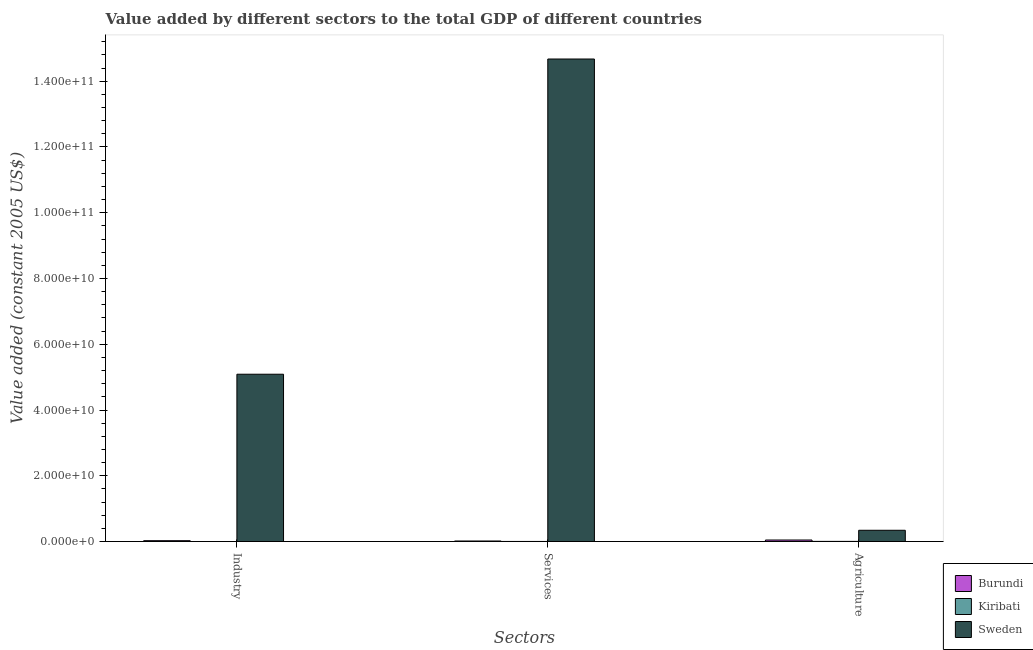How many groups of bars are there?
Provide a short and direct response. 3. Are the number of bars per tick equal to the number of legend labels?
Your response must be concise. Yes. How many bars are there on the 3rd tick from the right?
Make the answer very short. 3. What is the label of the 3rd group of bars from the left?
Provide a succinct answer. Agriculture. What is the value added by services in Kiribati?
Offer a terse response. 3.43e+07. Across all countries, what is the maximum value added by agricultural sector?
Make the answer very short. 3.43e+09. Across all countries, what is the minimum value added by industrial sector?
Your answer should be very brief. 6.78e+06. In which country was the value added by services maximum?
Your response must be concise. Sweden. In which country was the value added by services minimum?
Your answer should be very brief. Kiribati. What is the total value added by services in the graph?
Keep it short and to the point. 1.47e+11. What is the difference between the value added by industrial sector in Sweden and that in Burundi?
Your response must be concise. 5.06e+1. What is the difference between the value added by industrial sector in Burundi and the value added by services in Kiribati?
Provide a succinct answer. 2.32e+08. What is the average value added by agricultural sector per country?
Your response must be concise. 1.32e+09. What is the difference between the value added by services and value added by agricultural sector in Burundi?
Provide a succinct answer. -2.99e+08. What is the ratio of the value added by services in Burundi to that in Kiribati?
Give a very brief answer. 5.09. Is the value added by industrial sector in Sweden less than that in Kiribati?
Offer a very short reply. No. What is the difference between the highest and the second highest value added by industrial sector?
Offer a terse response. 5.06e+1. What is the difference between the highest and the lowest value added by industrial sector?
Your answer should be very brief. 5.09e+1. In how many countries, is the value added by industrial sector greater than the average value added by industrial sector taken over all countries?
Offer a very short reply. 1. Is the sum of the value added by agricultural sector in Kiribati and Sweden greater than the maximum value added by industrial sector across all countries?
Offer a very short reply. No. What does the 2nd bar from the left in Agriculture represents?
Offer a terse response. Kiribati. What does the 3rd bar from the right in Services represents?
Make the answer very short. Burundi. Is it the case that in every country, the sum of the value added by industrial sector and value added by services is greater than the value added by agricultural sector?
Your answer should be compact. No. What is the difference between two consecutive major ticks on the Y-axis?
Provide a short and direct response. 2.00e+1. Where does the legend appear in the graph?
Your response must be concise. Bottom right. What is the title of the graph?
Keep it short and to the point. Value added by different sectors to the total GDP of different countries. Does "Nepal" appear as one of the legend labels in the graph?
Ensure brevity in your answer.  No. What is the label or title of the X-axis?
Ensure brevity in your answer.  Sectors. What is the label or title of the Y-axis?
Provide a short and direct response. Value added (constant 2005 US$). What is the Value added (constant 2005 US$) of Burundi in Industry?
Ensure brevity in your answer.  2.66e+08. What is the Value added (constant 2005 US$) in Kiribati in Industry?
Give a very brief answer. 6.78e+06. What is the Value added (constant 2005 US$) in Sweden in Industry?
Your response must be concise. 5.09e+1. What is the Value added (constant 2005 US$) of Burundi in Services?
Provide a succinct answer. 1.75e+08. What is the Value added (constant 2005 US$) of Kiribati in Services?
Provide a short and direct response. 3.43e+07. What is the Value added (constant 2005 US$) of Sweden in Services?
Ensure brevity in your answer.  1.47e+11. What is the Value added (constant 2005 US$) in Burundi in Agriculture?
Your answer should be compact. 4.73e+08. What is the Value added (constant 2005 US$) in Kiribati in Agriculture?
Your answer should be compact. 5.42e+07. What is the Value added (constant 2005 US$) in Sweden in Agriculture?
Offer a terse response. 3.43e+09. Across all Sectors, what is the maximum Value added (constant 2005 US$) of Burundi?
Offer a very short reply. 4.73e+08. Across all Sectors, what is the maximum Value added (constant 2005 US$) in Kiribati?
Make the answer very short. 5.42e+07. Across all Sectors, what is the maximum Value added (constant 2005 US$) of Sweden?
Provide a short and direct response. 1.47e+11. Across all Sectors, what is the minimum Value added (constant 2005 US$) in Burundi?
Offer a very short reply. 1.75e+08. Across all Sectors, what is the minimum Value added (constant 2005 US$) of Kiribati?
Your answer should be very brief. 6.78e+06. Across all Sectors, what is the minimum Value added (constant 2005 US$) of Sweden?
Your answer should be very brief. 3.43e+09. What is the total Value added (constant 2005 US$) of Burundi in the graph?
Offer a terse response. 9.14e+08. What is the total Value added (constant 2005 US$) in Kiribati in the graph?
Ensure brevity in your answer.  9.53e+07. What is the total Value added (constant 2005 US$) in Sweden in the graph?
Your answer should be compact. 2.01e+11. What is the difference between the Value added (constant 2005 US$) of Burundi in Industry and that in Services?
Your answer should be very brief. 9.19e+07. What is the difference between the Value added (constant 2005 US$) in Kiribati in Industry and that in Services?
Keep it short and to the point. -2.75e+07. What is the difference between the Value added (constant 2005 US$) of Sweden in Industry and that in Services?
Keep it short and to the point. -9.59e+1. What is the difference between the Value added (constant 2005 US$) of Burundi in Industry and that in Agriculture?
Ensure brevity in your answer.  -2.07e+08. What is the difference between the Value added (constant 2005 US$) of Kiribati in Industry and that in Agriculture?
Offer a terse response. -4.74e+07. What is the difference between the Value added (constant 2005 US$) of Sweden in Industry and that in Agriculture?
Ensure brevity in your answer.  4.75e+1. What is the difference between the Value added (constant 2005 US$) of Burundi in Services and that in Agriculture?
Give a very brief answer. -2.99e+08. What is the difference between the Value added (constant 2005 US$) in Kiribati in Services and that in Agriculture?
Give a very brief answer. -1.99e+07. What is the difference between the Value added (constant 2005 US$) in Sweden in Services and that in Agriculture?
Provide a succinct answer. 1.43e+11. What is the difference between the Value added (constant 2005 US$) in Burundi in Industry and the Value added (constant 2005 US$) in Kiribati in Services?
Keep it short and to the point. 2.32e+08. What is the difference between the Value added (constant 2005 US$) in Burundi in Industry and the Value added (constant 2005 US$) in Sweden in Services?
Your answer should be very brief. -1.46e+11. What is the difference between the Value added (constant 2005 US$) of Kiribati in Industry and the Value added (constant 2005 US$) of Sweden in Services?
Offer a very short reply. -1.47e+11. What is the difference between the Value added (constant 2005 US$) of Burundi in Industry and the Value added (constant 2005 US$) of Kiribati in Agriculture?
Your answer should be very brief. 2.12e+08. What is the difference between the Value added (constant 2005 US$) in Burundi in Industry and the Value added (constant 2005 US$) in Sweden in Agriculture?
Ensure brevity in your answer.  -3.17e+09. What is the difference between the Value added (constant 2005 US$) of Kiribati in Industry and the Value added (constant 2005 US$) of Sweden in Agriculture?
Make the answer very short. -3.43e+09. What is the difference between the Value added (constant 2005 US$) in Burundi in Services and the Value added (constant 2005 US$) in Kiribati in Agriculture?
Ensure brevity in your answer.  1.20e+08. What is the difference between the Value added (constant 2005 US$) in Burundi in Services and the Value added (constant 2005 US$) in Sweden in Agriculture?
Provide a short and direct response. -3.26e+09. What is the difference between the Value added (constant 2005 US$) of Kiribati in Services and the Value added (constant 2005 US$) of Sweden in Agriculture?
Offer a very short reply. -3.40e+09. What is the average Value added (constant 2005 US$) of Burundi per Sectors?
Offer a very short reply. 3.05e+08. What is the average Value added (constant 2005 US$) in Kiribati per Sectors?
Provide a short and direct response. 3.18e+07. What is the average Value added (constant 2005 US$) in Sweden per Sectors?
Your response must be concise. 6.70e+1. What is the difference between the Value added (constant 2005 US$) of Burundi and Value added (constant 2005 US$) of Kiribati in Industry?
Your response must be concise. 2.60e+08. What is the difference between the Value added (constant 2005 US$) in Burundi and Value added (constant 2005 US$) in Sweden in Industry?
Your answer should be very brief. -5.06e+1. What is the difference between the Value added (constant 2005 US$) in Kiribati and Value added (constant 2005 US$) in Sweden in Industry?
Your response must be concise. -5.09e+1. What is the difference between the Value added (constant 2005 US$) of Burundi and Value added (constant 2005 US$) of Kiribati in Services?
Ensure brevity in your answer.  1.40e+08. What is the difference between the Value added (constant 2005 US$) of Burundi and Value added (constant 2005 US$) of Sweden in Services?
Your answer should be compact. -1.47e+11. What is the difference between the Value added (constant 2005 US$) in Kiribati and Value added (constant 2005 US$) in Sweden in Services?
Give a very brief answer. -1.47e+11. What is the difference between the Value added (constant 2005 US$) in Burundi and Value added (constant 2005 US$) in Kiribati in Agriculture?
Offer a terse response. 4.19e+08. What is the difference between the Value added (constant 2005 US$) of Burundi and Value added (constant 2005 US$) of Sweden in Agriculture?
Provide a short and direct response. -2.96e+09. What is the difference between the Value added (constant 2005 US$) of Kiribati and Value added (constant 2005 US$) of Sweden in Agriculture?
Provide a short and direct response. -3.38e+09. What is the ratio of the Value added (constant 2005 US$) of Burundi in Industry to that in Services?
Your response must be concise. 1.53. What is the ratio of the Value added (constant 2005 US$) in Kiribati in Industry to that in Services?
Offer a terse response. 0.2. What is the ratio of the Value added (constant 2005 US$) of Sweden in Industry to that in Services?
Your answer should be very brief. 0.35. What is the ratio of the Value added (constant 2005 US$) of Burundi in Industry to that in Agriculture?
Give a very brief answer. 0.56. What is the ratio of the Value added (constant 2005 US$) of Kiribati in Industry to that in Agriculture?
Offer a very short reply. 0.13. What is the ratio of the Value added (constant 2005 US$) of Sweden in Industry to that in Agriculture?
Offer a very short reply. 14.82. What is the ratio of the Value added (constant 2005 US$) in Burundi in Services to that in Agriculture?
Provide a succinct answer. 0.37. What is the ratio of the Value added (constant 2005 US$) of Kiribati in Services to that in Agriculture?
Keep it short and to the point. 0.63. What is the ratio of the Value added (constant 2005 US$) in Sweden in Services to that in Agriculture?
Your answer should be very brief. 42.75. What is the difference between the highest and the second highest Value added (constant 2005 US$) in Burundi?
Make the answer very short. 2.07e+08. What is the difference between the highest and the second highest Value added (constant 2005 US$) in Kiribati?
Keep it short and to the point. 1.99e+07. What is the difference between the highest and the second highest Value added (constant 2005 US$) of Sweden?
Your response must be concise. 9.59e+1. What is the difference between the highest and the lowest Value added (constant 2005 US$) of Burundi?
Offer a terse response. 2.99e+08. What is the difference between the highest and the lowest Value added (constant 2005 US$) of Kiribati?
Your response must be concise. 4.74e+07. What is the difference between the highest and the lowest Value added (constant 2005 US$) in Sweden?
Provide a succinct answer. 1.43e+11. 